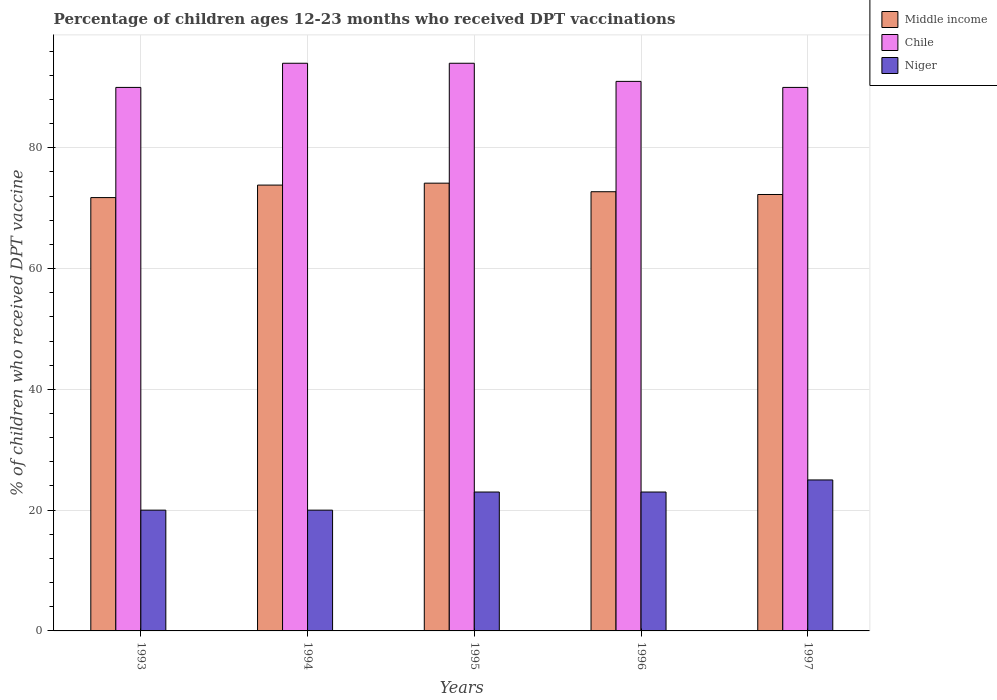How many different coloured bars are there?
Your answer should be very brief. 3. How many groups of bars are there?
Offer a terse response. 5. How many bars are there on the 5th tick from the right?
Offer a terse response. 3. In how many cases, is the number of bars for a given year not equal to the number of legend labels?
Your response must be concise. 0. What is the percentage of children who received DPT vaccination in Middle income in 1997?
Your answer should be very brief. 72.27. Across all years, what is the maximum percentage of children who received DPT vaccination in Middle income?
Provide a short and direct response. 74.14. Across all years, what is the minimum percentage of children who received DPT vaccination in Chile?
Provide a succinct answer. 90. What is the total percentage of children who received DPT vaccination in Chile in the graph?
Your response must be concise. 459. What is the difference between the percentage of children who received DPT vaccination in Niger in 1994 and that in 1995?
Ensure brevity in your answer.  -3. What is the difference between the percentage of children who received DPT vaccination in Niger in 1993 and the percentage of children who received DPT vaccination in Middle income in 1994?
Offer a terse response. -53.83. What is the average percentage of children who received DPT vaccination in Chile per year?
Give a very brief answer. 91.8. In the year 1993, what is the difference between the percentage of children who received DPT vaccination in Niger and percentage of children who received DPT vaccination in Middle income?
Provide a succinct answer. -51.76. What is the ratio of the percentage of children who received DPT vaccination in Chile in 1993 to that in 1996?
Keep it short and to the point. 0.99. Is the percentage of children who received DPT vaccination in Niger in 1994 less than that in 1995?
Your answer should be compact. Yes. What is the difference between the highest and the second highest percentage of children who received DPT vaccination in Chile?
Provide a short and direct response. 0. What is the difference between the highest and the lowest percentage of children who received DPT vaccination in Chile?
Provide a succinct answer. 4. What does the 2nd bar from the right in 1997 represents?
Your response must be concise. Chile. Is it the case that in every year, the sum of the percentage of children who received DPT vaccination in Chile and percentage of children who received DPT vaccination in Middle income is greater than the percentage of children who received DPT vaccination in Niger?
Provide a short and direct response. Yes. How many bars are there?
Provide a succinct answer. 15. Does the graph contain grids?
Give a very brief answer. Yes. What is the title of the graph?
Keep it short and to the point. Percentage of children ages 12-23 months who received DPT vaccinations. What is the label or title of the X-axis?
Make the answer very short. Years. What is the label or title of the Y-axis?
Your response must be concise. % of children who received DPT vaccine. What is the % of children who received DPT vaccine of Middle income in 1993?
Offer a terse response. 71.76. What is the % of children who received DPT vaccine in Niger in 1993?
Ensure brevity in your answer.  20. What is the % of children who received DPT vaccine in Middle income in 1994?
Keep it short and to the point. 73.83. What is the % of children who received DPT vaccine in Chile in 1994?
Your answer should be very brief. 94. What is the % of children who received DPT vaccine in Middle income in 1995?
Give a very brief answer. 74.14. What is the % of children who received DPT vaccine in Chile in 1995?
Ensure brevity in your answer.  94. What is the % of children who received DPT vaccine in Middle income in 1996?
Make the answer very short. 72.73. What is the % of children who received DPT vaccine of Chile in 1996?
Keep it short and to the point. 91. What is the % of children who received DPT vaccine of Middle income in 1997?
Your response must be concise. 72.27. What is the % of children who received DPT vaccine in Chile in 1997?
Make the answer very short. 90. Across all years, what is the maximum % of children who received DPT vaccine in Middle income?
Your response must be concise. 74.14. Across all years, what is the maximum % of children who received DPT vaccine of Chile?
Provide a succinct answer. 94. Across all years, what is the minimum % of children who received DPT vaccine in Middle income?
Offer a very short reply. 71.76. What is the total % of children who received DPT vaccine of Middle income in the graph?
Offer a very short reply. 364.72. What is the total % of children who received DPT vaccine of Chile in the graph?
Provide a short and direct response. 459. What is the total % of children who received DPT vaccine of Niger in the graph?
Your response must be concise. 111. What is the difference between the % of children who received DPT vaccine of Middle income in 1993 and that in 1994?
Ensure brevity in your answer.  -2.07. What is the difference between the % of children who received DPT vaccine of Niger in 1993 and that in 1994?
Keep it short and to the point. 0. What is the difference between the % of children who received DPT vaccine in Middle income in 1993 and that in 1995?
Offer a terse response. -2.39. What is the difference between the % of children who received DPT vaccine in Chile in 1993 and that in 1995?
Your answer should be very brief. -4. What is the difference between the % of children who received DPT vaccine in Niger in 1993 and that in 1995?
Your answer should be compact. -3. What is the difference between the % of children who received DPT vaccine of Middle income in 1993 and that in 1996?
Keep it short and to the point. -0.97. What is the difference between the % of children who received DPT vaccine of Niger in 1993 and that in 1996?
Your response must be concise. -3. What is the difference between the % of children who received DPT vaccine of Middle income in 1993 and that in 1997?
Provide a succinct answer. -0.51. What is the difference between the % of children who received DPT vaccine in Niger in 1993 and that in 1997?
Ensure brevity in your answer.  -5. What is the difference between the % of children who received DPT vaccine in Middle income in 1994 and that in 1995?
Offer a very short reply. -0.32. What is the difference between the % of children who received DPT vaccine of Chile in 1994 and that in 1995?
Your answer should be very brief. 0. What is the difference between the % of children who received DPT vaccine of Niger in 1994 and that in 1995?
Keep it short and to the point. -3. What is the difference between the % of children who received DPT vaccine in Middle income in 1994 and that in 1996?
Keep it short and to the point. 1.1. What is the difference between the % of children who received DPT vaccine of Middle income in 1994 and that in 1997?
Make the answer very short. 1.56. What is the difference between the % of children who received DPT vaccine in Niger in 1994 and that in 1997?
Keep it short and to the point. -5. What is the difference between the % of children who received DPT vaccine in Middle income in 1995 and that in 1996?
Your answer should be compact. 1.42. What is the difference between the % of children who received DPT vaccine of Middle income in 1995 and that in 1997?
Your response must be concise. 1.87. What is the difference between the % of children who received DPT vaccine in Niger in 1995 and that in 1997?
Your answer should be very brief. -2. What is the difference between the % of children who received DPT vaccine of Middle income in 1996 and that in 1997?
Your answer should be very brief. 0.46. What is the difference between the % of children who received DPT vaccine in Niger in 1996 and that in 1997?
Your answer should be compact. -2. What is the difference between the % of children who received DPT vaccine in Middle income in 1993 and the % of children who received DPT vaccine in Chile in 1994?
Your response must be concise. -22.24. What is the difference between the % of children who received DPT vaccine in Middle income in 1993 and the % of children who received DPT vaccine in Niger in 1994?
Keep it short and to the point. 51.76. What is the difference between the % of children who received DPT vaccine in Chile in 1993 and the % of children who received DPT vaccine in Niger in 1994?
Provide a succinct answer. 70. What is the difference between the % of children who received DPT vaccine in Middle income in 1993 and the % of children who received DPT vaccine in Chile in 1995?
Provide a succinct answer. -22.24. What is the difference between the % of children who received DPT vaccine of Middle income in 1993 and the % of children who received DPT vaccine of Niger in 1995?
Provide a succinct answer. 48.76. What is the difference between the % of children who received DPT vaccine in Middle income in 1993 and the % of children who received DPT vaccine in Chile in 1996?
Make the answer very short. -19.24. What is the difference between the % of children who received DPT vaccine in Middle income in 1993 and the % of children who received DPT vaccine in Niger in 1996?
Provide a short and direct response. 48.76. What is the difference between the % of children who received DPT vaccine in Middle income in 1993 and the % of children who received DPT vaccine in Chile in 1997?
Your answer should be compact. -18.24. What is the difference between the % of children who received DPT vaccine in Middle income in 1993 and the % of children who received DPT vaccine in Niger in 1997?
Offer a very short reply. 46.76. What is the difference between the % of children who received DPT vaccine of Chile in 1993 and the % of children who received DPT vaccine of Niger in 1997?
Ensure brevity in your answer.  65. What is the difference between the % of children who received DPT vaccine in Middle income in 1994 and the % of children who received DPT vaccine in Chile in 1995?
Ensure brevity in your answer.  -20.17. What is the difference between the % of children who received DPT vaccine of Middle income in 1994 and the % of children who received DPT vaccine of Niger in 1995?
Make the answer very short. 50.83. What is the difference between the % of children who received DPT vaccine in Chile in 1994 and the % of children who received DPT vaccine in Niger in 1995?
Provide a succinct answer. 71. What is the difference between the % of children who received DPT vaccine of Middle income in 1994 and the % of children who received DPT vaccine of Chile in 1996?
Provide a short and direct response. -17.17. What is the difference between the % of children who received DPT vaccine of Middle income in 1994 and the % of children who received DPT vaccine of Niger in 1996?
Make the answer very short. 50.83. What is the difference between the % of children who received DPT vaccine of Chile in 1994 and the % of children who received DPT vaccine of Niger in 1996?
Your answer should be very brief. 71. What is the difference between the % of children who received DPT vaccine of Middle income in 1994 and the % of children who received DPT vaccine of Chile in 1997?
Make the answer very short. -16.17. What is the difference between the % of children who received DPT vaccine of Middle income in 1994 and the % of children who received DPT vaccine of Niger in 1997?
Make the answer very short. 48.83. What is the difference between the % of children who received DPT vaccine of Middle income in 1995 and the % of children who received DPT vaccine of Chile in 1996?
Offer a very short reply. -16.86. What is the difference between the % of children who received DPT vaccine of Middle income in 1995 and the % of children who received DPT vaccine of Niger in 1996?
Make the answer very short. 51.14. What is the difference between the % of children who received DPT vaccine of Middle income in 1995 and the % of children who received DPT vaccine of Chile in 1997?
Provide a short and direct response. -15.86. What is the difference between the % of children who received DPT vaccine of Middle income in 1995 and the % of children who received DPT vaccine of Niger in 1997?
Provide a short and direct response. 49.14. What is the difference between the % of children who received DPT vaccine in Middle income in 1996 and the % of children who received DPT vaccine in Chile in 1997?
Your answer should be very brief. -17.27. What is the difference between the % of children who received DPT vaccine of Middle income in 1996 and the % of children who received DPT vaccine of Niger in 1997?
Your answer should be compact. 47.73. What is the difference between the % of children who received DPT vaccine of Chile in 1996 and the % of children who received DPT vaccine of Niger in 1997?
Your answer should be compact. 66. What is the average % of children who received DPT vaccine of Middle income per year?
Offer a very short reply. 72.94. What is the average % of children who received DPT vaccine in Chile per year?
Make the answer very short. 91.8. In the year 1993, what is the difference between the % of children who received DPT vaccine in Middle income and % of children who received DPT vaccine in Chile?
Your answer should be very brief. -18.24. In the year 1993, what is the difference between the % of children who received DPT vaccine in Middle income and % of children who received DPT vaccine in Niger?
Make the answer very short. 51.76. In the year 1993, what is the difference between the % of children who received DPT vaccine of Chile and % of children who received DPT vaccine of Niger?
Your answer should be compact. 70. In the year 1994, what is the difference between the % of children who received DPT vaccine in Middle income and % of children who received DPT vaccine in Chile?
Your answer should be compact. -20.17. In the year 1994, what is the difference between the % of children who received DPT vaccine of Middle income and % of children who received DPT vaccine of Niger?
Make the answer very short. 53.83. In the year 1995, what is the difference between the % of children who received DPT vaccine in Middle income and % of children who received DPT vaccine in Chile?
Your answer should be compact. -19.86. In the year 1995, what is the difference between the % of children who received DPT vaccine of Middle income and % of children who received DPT vaccine of Niger?
Provide a succinct answer. 51.14. In the year 1995, what is the difference between the % of children who received DPT vaccine in Chile and % of children who received DPT vaccine in Niger?
Provide a succinct answer. 71. In the year 1996, what is the difference between the % of children who received DPT vaccine of Middle income and % of children who received DPT vaccine of Chile?
Keep it short and to the point. -18.27. In the year 1996, what is the difference between the % of children who received DPT vaccine in Middle income and % of children who received DPT vaccine in Niger?
Give a very brief answer. 49.73. In the year 1997, what is the difference between the % of children who received DPT vaccine in Middle income and % of children who received DPT vaccine in Chile?
Your answer should be compact. -17.73. In the year 1997, what is the difference between the % of children who received DPT vaccine of Middle income and % of children who received DPT vaccine of Niger?
Make the answer very short. 47.27. What is the ratio of the % of children who received DPT vaccine of Chile in 1993 to that in 1994?
Provide a short and direct response. 0.96. What is the ratio of the % of children who received DPT vaccine in Middle income in 1993 to that in 1995?
Offer a terse response. 0.97. What is the ratio of the % of children who received DPT vaccine in Chile in 1993 to that in 1995?
Your response must be concise. 0.96. What is the ratio of the % of children who received DPT vaccine in Niger in 1993 to that in 1995?
Provide a succinct answer. 0.87. What is the ratio of the % of children who received DPT vaccine in Middle income in 1993 to that in 1996?
Keep it short and to the point. 0.99. What is the ratio of the % of children who received DPT vaccine of Chile in 1993 to that in 1996?
Your answer should be very brief. 0.99. What is the ratio of the % of children who received DPT vaccine of Niger in 1993 to that in 1996?
Keep it short and to the point. 0.87. What is the ratio of the % of children who received DPT vaccine of Niger in 1993 to that in 1997?
Your response must be concise. 0.8. What is the ratio of the % of children who received DPT vaccine in Chile in 1994 to that in 1995?
Your response must be concise. 1. What is the ratio of the % of children who received DPT vaccine in Niger in 1994 to that in 1995?
Your answer should be very brief. 0.87. What is the ratio of the % of children who received DPT vaccine in Middle income in 1994 to that in 1996?
Your response must be concise. 1.02. What is the ratio of the % of children who received DPT vaccine in Chile in 1994 to that in 1996?
Your response must be concise. 1.03. What is the ratio of the % of children who received DPT vaccine of Niger in 1994 to that in 1996?
Your answer should be compact. 0.87. What is the ratio of the % of children who received DPT vaccine of Middle income in 1994 to that in 1997?
Offer a terse response. 1.02. What is the ratio of the % of children who received DPT vaccine of Chile in 1994 to that in 1997?
Your answer should be very brief. 1.04. What is the ratio of the % of children who received DPT vaccine of Middle income in 1995 to that in 1996?
Provide a short and direct response. 1.02. What is the ratio of the % of children who received DPT vaccine in Chile in 1995 to that in 1996?
Give a very brief answer. 1.03. What is the ratio of the % of children who received DPT vaccine in Niger in 1995 to that in 1996?
Keep it short and to the point. 1. What is the ratio of the % of children who received DPT vaccine of Middle income in 1995 to that in 1997?
Your answer should be compact. 1.03. What is the ratio of the % of children who received DPT vaccine of Chile in 1995 to that in 1997?
Provide a short and direct response. 1.04. What is the ratio of the % of children who received DPT vaccine in Chile in 1996 to that in 1997?
Give a very brief answer. 1.01. What is the ratio of the % of children who received DPT vaccine in Niger in 1996 to that in 1997?
Your answer should be compact. 0.92. What is the difference between the highest and the second highest % of children who received DPT vaccine in Middle income?
Your response must be concise. 0.32. What is the difference between the highest and the lowest % of children who received DPT vaccine in Middle income?
Provide a short and direct response. 2.39. 